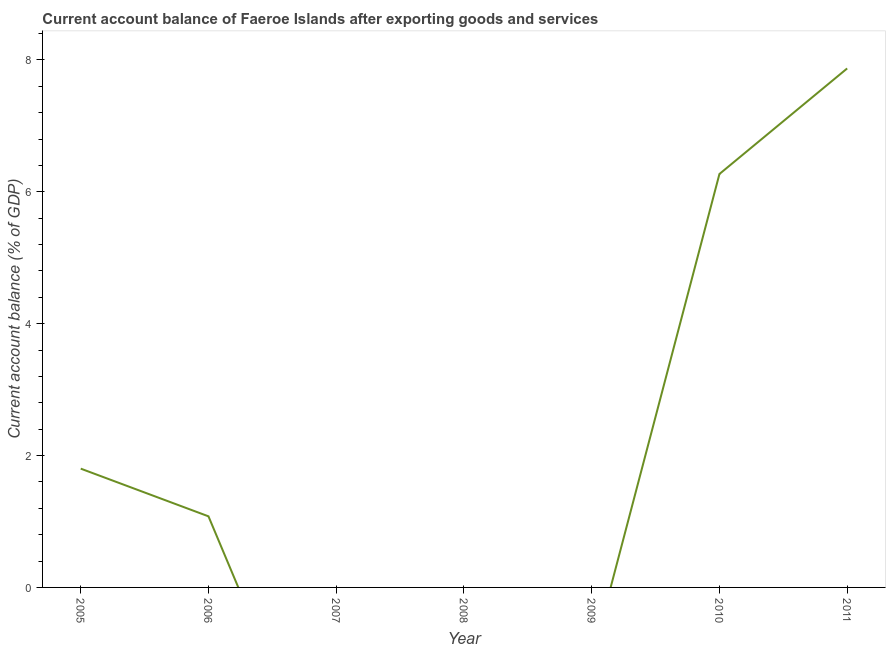What is the current account balance in 2010?
Your response must be concise. 6.27. Across all years, what is the maximum current account balance?
Give a very brief answer. 7.87. In which year was the current account balance maximum?
Provide a short and direct response. 2011. What is the sum of the current account balance?
Offer a terse response. 17.02. What is the difference between the current account balance in 2010 and 2011?
Provide a succinct answer. -1.6. What is the average current account balance per year?
Make the answer very short. 2.43. What is the median current account balance?
Your response must be concise. 1.08. In how many years, is the current account balance greater than 4 %?
Provide a succinct answer. 2. What is the ratio of the current account balance in 2005 to that in 2011?
Your answer should be compact. 0.23. What is the difference between the highest and the second highest current account balance?
Offer a terse response. 1.6. Is the sum of the current account balance in 2005 and 2006 greater than the maximum current account balance across all years?
Your response must be concise. No. What is the difference between the highest and the lowest current account balance?
Your answer should be compact. 7.87. How many lines are there?
Your response must be concise. 1. How many years are there in the graph?
Your response must be concise. 7. What is the difference between two consecutive major ticks on the Y-axis?
Ensure brevity in your answer.  2. Are the values on the major ticks of Y-axis written in scientific E-notation?
Offer a very short reply. No. Does the graph contain any zero values?
Keep it short and to the point. Yes. Does the graph contain grids?
Your answer should be compact. No. What is the title of the graph?
Your answer should be compact. Current account balance of Faeroe Islands after exporting goods and services. What is the label or title of the X-axis?
Offer a terse response. Year. What is the label or title of the Y-axis?
Provide a short and direct response. Current account balance (% of GDP). What is the Current account balance (% of GDP) of 2005?
Make the answer very short. 1.8. What is the Current account balance (% of GDP) in 2006?
Keep it short and to the point. 1.08. What is the Current account balance (% of GDP) in 2007?
Offer a terse response. 0. What is the Current account balance (% of GDP) in 2008?
Provide a succinct answer. 0. What is the Current account balance (% of GDP) of 2010?
Provide a short and direct response. 6.27. What is the Current account balance (% of GDP) in 2011?
Offer a terse response. 7.87. What is the difference between the Current account balance (% of GDP) in 2005 and 2006?
Make the answer very short. 0.72. What is the difference between the Current account balance (% of GDP) in 2005 and 2010?
Your answer should be very brief. -4.47. What is the difference between the Current account balance (% of GDP) in 2005 and 2011?
Provide a succinct answer. -6.07. What is the difference between the Current account balance (% of GDP) in 2006 and 2010?
Give a very brief answer. -5.19. What is the difference between the Current account balance (% of GDP) in 2006 and 2011?
Offer a terse response. -6.79. What is the difference between the Current account balance (% of GDP) in 2010 and 2011?
Make the answer very short. -1.6. What is the ratio of the Current account balance (% of GDP) in 2005 to that in 2006?
Provide a short and direct response. 1.67. What is the ratio of the Current account balance (% of GDP) in 2005 to that in 2010?
Keep it short and to the point. 0.29. What is the ratio of the Current account balance (% of GDP) in 2005 to that in 2011?
Ensure brevity in your answer.  0.23. What is the ratio of the Current account balance (% of GDP) in 2006 to that in 2010?
Your response must be concise. 0.17. What is the ratio of the Current account balance (% of GDP) in 2006 to that in 2011?
Ensure brevity in your answer.  0.14. What is the ratio of the Current account balance (% of GDP) in 2010 to that in 2011?
Offer a terse response. 0.8. 